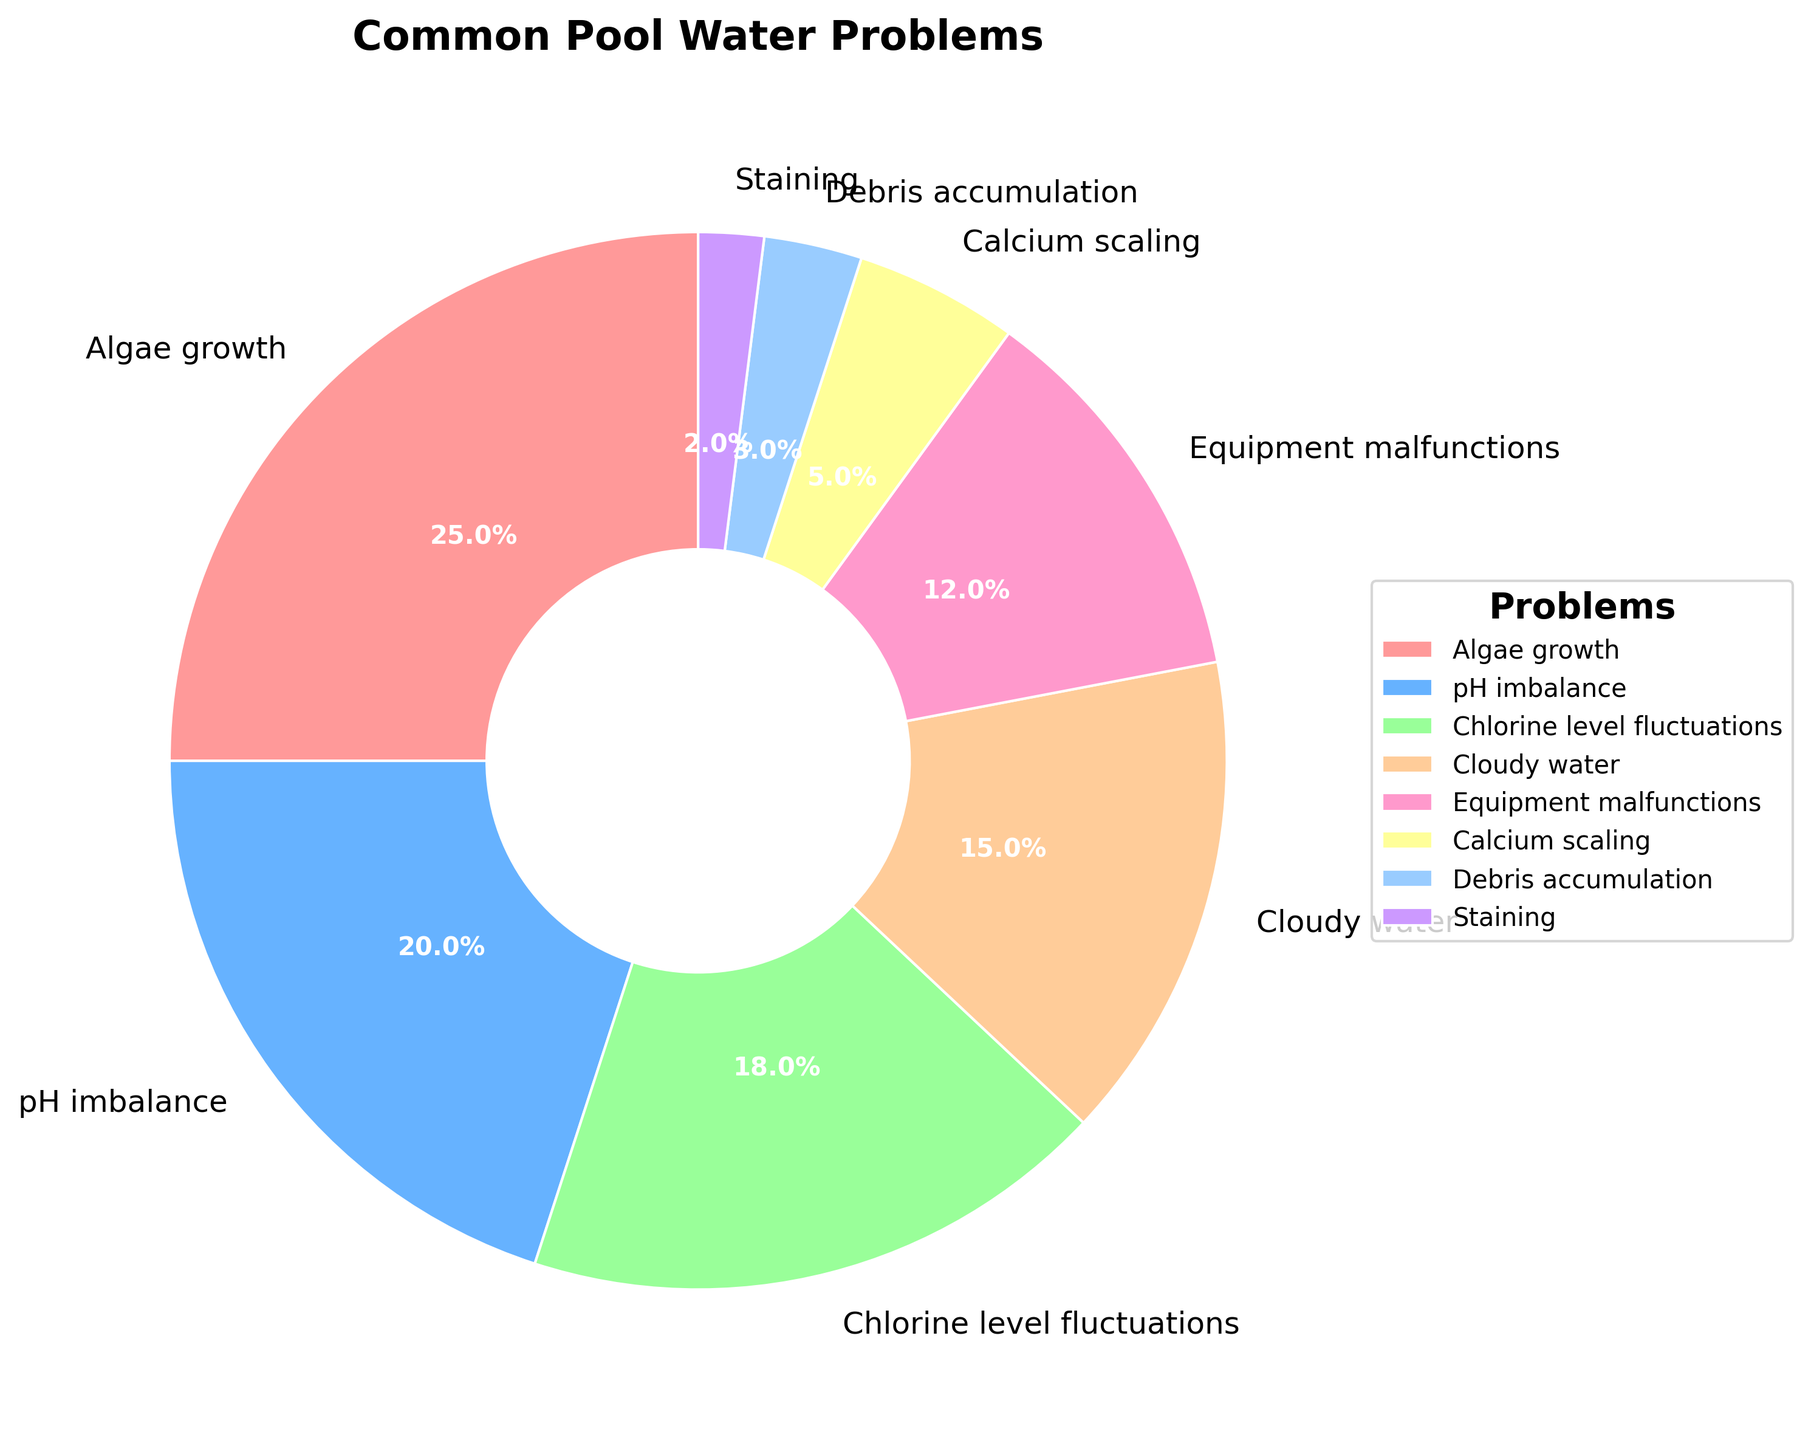Which problem is the most common among homeowners? The pie chart shows that algae growth has the largest segment at 25%.
Answer: Algae growth Which problem is encountered less frequently: chlorine level fluctuations or equipment malfunctions? The pie chart shows chlorine level fluctuations at 18% and equipment malfunctions at 12%, so equipment malfunctions are less frequent.
Answer: Equipment malfunctions What is the combined percentage of algae growth and pH imbalance problems? Algae growth accounts for 25% and pH imbalance for 20%. Adding them together: 25% + 20% = 45%.
Answer: 45% How does the occurrence of cloudy water problems compare to that of calcium scaling? Cloudy water is shown at 15% and calcium scaling at 5%, so cloudy water problems occur more frequently.
Answer: Cloudy water occurs more frequently Which problem has the smallest percentage, and what is it? The smallest segment on the pie chart is staining, which is 2%.
Answer: Staining, 2% Are chlorine level fluctuations more common than pH imbalances? Chlorine level fluctuations are shown at 18%, whereas pH imbalances are at 20%. The pie chart indicates that pH imbalances are more common.
Answer: No What is the total percentage of less common problems (less than 10%)? Summing up the percentages for less common problems: Calcium scaling (5%), Debris accumulation (3%), and Staining (2%): 5% + 3% + 2% = 10%.
Answer: 10% What are the three most common pool problems, according to the chart? The three largest segments on the pie chart are algae growth (25%), pH imbalance (20%), and chlorine level fluctuations (18%).
Answer: Algae growth, pH imbalance, chlorine level fluctuations By how much does the percentage of algae growth exceed that of cloudy water? Algae growth is 25%, and cloudy water is 15%. Subtracting the percentage of cloudy water from algae growth: 25% - 15% = 10%.
Answer: 10% 